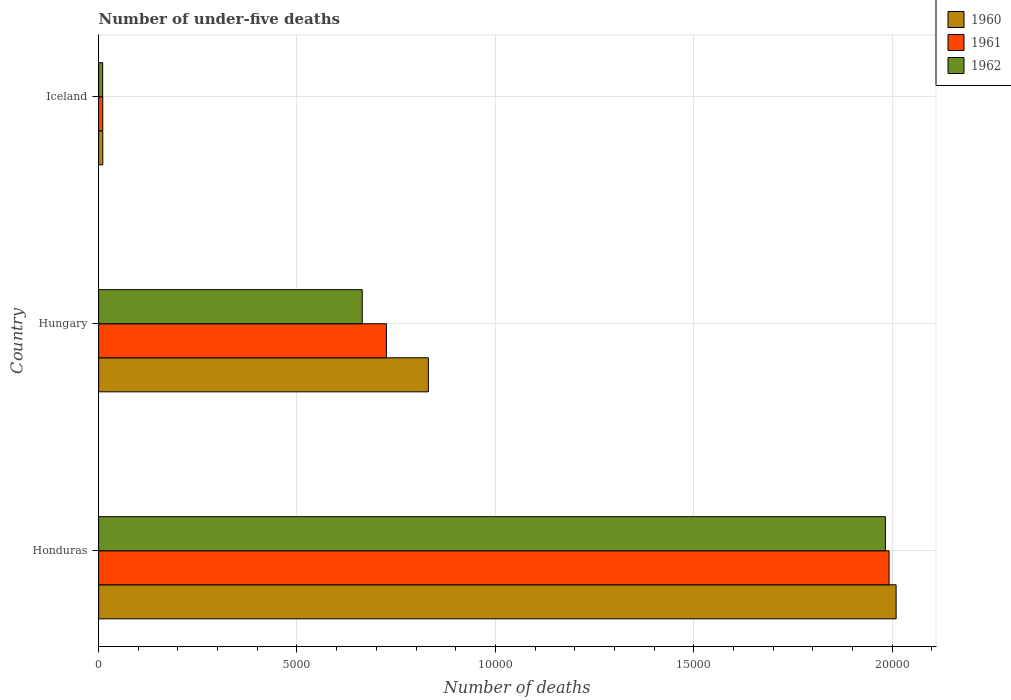How many groups of bars are there?
Give a very brief answer. 3. How many bars are there on the 1st tick from the bottom?
Make the answer very short. 3. What is the label of the 2nd group of bars from the top?
Provide a short and direct response. Hungary. In how many cases, is the number of bars for a given country not equal to the number of legend labels?
Offer a terse response. 0. What is the number of under-five deaths in 1962 in Hungary?
Offer a very short reply. 6645. Across all countries, what is the maximum number of under-five deaths in 1962?
Provide a succinct answer. 1.98e+04. Across all countries, what is the minimum number of under-five deaths in 1962?
Your response must be concise. 102. In which country was the number of under-five deaths in 1960 maximum?
Offer a terse response. Honduras. In which country was the number of under-five deaths in 1960 minimum?
Ensure brevity in your answer.  Iceland. What is the total number of under-five deaths in 1961 in the graph?
Keep it short and to the point. 2.73e+04. What is the difference between the number of under-five deaths in 1961 in Honduras and that in Hungary?
Provide a succinct answer. 1.27e+04. What is the difference between the number of under-five deaths in 1961 in Iceland and the number of under-five deaths in 1960 in Hungary?
Provide a succinct answer. -8208. What is the average number of under-five deaths in 1960 per country?
Your answer should be very brief. 9506.67. What is the difference between the number of under-five deaths in 1962 and number of under-five deaths in 1960 in Hungary?
Make the answer very short. -1667. In how many countries, is the number of under-five deaths in 1962 greater than 19000 ?
Keep it short and to the point. 1. What is the ratio of the number of under-five deaths in 1961 in Hungary to that in Iceland?
Keep it short and to the point. 69.76. Is the number of under-five deaths in 1961 in Honduras less than that in Hungary?
Your answer should be very brief. No. Is the difference between the number of under-five deaths in 1962 in Honduras and Hungary greater than the difference between the number of under-five deaths in 1960 in Honduras and Hungary?
Offer a very short reply. Yes. What is the difference between the highest and the second highest number of under-five deaths in 1962?
Provide a short and direct response. 1.32e+04. What is the difference between the highest and the lowest number of under-five deaths in 1960?
Your answer should be very brief. 2.00e+04. What does the 3rd bar from the bottom in Hungary represents?
Give a very brief answer. 1962. Is it the case that in every country, the sum of the number of under-five deaths in 1961 and number of under-five deaths in 1962 is greater than the number of under-five deaths in 1960?
Offer a terse response. Yes. How many countries are there in the graph?
Offer a terse response. 3. What is the difference between two consecutive major ticks on the X-axis?
Offer a terse response. 5000. Does the graph contain grids?
Give a very brief answer. Yes. Where does the legend appear in the graph?
Your answer should be compact. Top right. How are the legend labels stacked?
Keep it short and to the point. Vertical. What is the title of the graph?
Offer a very short reply. Number of under-five deaths. Does "1962" appear as one of the legend labels in the graph?
Your answer should be compact. Yes. What is the label or title of the X-axis?
Give a very brief answer. Number of deaths. What is the label or title of the Y-axis?
Ensure brevity in your answer.  Country. What is the Number of deaths of 1960 in Honduras?
Ensure brevity in your answer.  2.01e+04. What is the Number of deaths in 1961 in Honduras?
Offer a terse response. 1.99e+04. What is the Number of deaths of 1962 in Honduras?
Your answer should be compact. 1.98e+04. What is the Number of deaths in 1960 in Hungary?
Ensure brevity in your answer.  8312. What is the Number of deaths of 1961 in Hungary?
Offer a very short reply. 7255. What is the Number of deaths in 1962 in Hungary?
Your answer should be compact. 6645. What is the Number of deaths of 1960 in Iceland?
Make the answer very short. 105. What is the Number of deaths in 1961 in Iceland?
Keep it short and to the point. 104. What is the Number of deaths of 1962 in Iceland?
Your response must be concise. 102. Across all countries, what is the maximum Number of deaths of 1960?
Provide a short and direct response. 2.01e+04. Across all countries, what is the maximum Number of deaths of 1961?
Offer a terse response. 1.99e+04. Across all countries, what is the maximum Number of deaths in 1962?
Provide a succinct answer. 1.98e+04. Across all countries, what is the minimum Number of deaths of 1960?
Offer a terse response. 105. Across all countries, what is the minimum Number of deaths in 1961?
Give a very brief answer. 104. Across all countries, what is the minimum Number of deaths of 1962?
Ensure brevity in your answer.  102. What is the total Number of deaths in 1960 in the graph?
Keep it short and to the point. 2.85e+04. What is the total Number of deaths in 1961 in the graph?
Keep it short and to the point. 2.73e+04. What is the total Number of deaths in 1962 in the graph?
Provide a succinct answer. 2.66e+04. What is the difference between the Number of deaths of 1960 in Honduras and that in Hungary?
Your answer should be compact. 1.18e+04. What is the difference between the Number of deaths of 1961 in Honduras and that in Hungary?
Give a very brief answer. 1.27e+04. What is the difference between the Number of deaths of 1962 in Honduras and that in Hungary?
Keep it short and to the point. 1.32e+04. What is the difference between the Number of deaths of 1960 in Honduras and that in Iceland?
Offer a very short reply. 2.00e+04. What is the difference between the Number of deaths in 1961 in Honduras and that in Iceland?
Provide a short and direct response. 1.98e+04. What is the difference between the Number of deaths of 1962 in Honduras and that in Iceland?
Your response must be concise. 1.97e+04. What is the difference between the Number of deaths in 1960 in Hungary and that in Iceland?
Ensure brevity in your answer.  8207. What is the difference between the Number of deaths of 1961 in Hungary and that in Iceland?
Keep it short and to the point. 7151. What is the difference between the Number of deaths in 1962 in Hungary and that in Iceland?
Your answer should be compact. 6543. What is the difference between the Number of deaths of 1960 in Honduras and the Number of deaths of 1961 in Hungary?
Your answer should be compact. 1.28e+04. What is the difference between the Number of deaths in 1960 in Honduras and the Number of deaths in 1962 in Hungary?
Keep it short and to the point. 1.35e+04. What is the difference between the Number of deaths in 1961 in Honduras and the Number of deaths in 1962 in Hungary?
Ensure brevity in your answer.  1.33e+04. What is the difference between the Number of deaths of 1960 in Honduras and the Number of deaths of 1961 in Iceland?
Ensure brevity in your answer.  2.00e+04. What is the difference between the Number of deaths in 1960 in Honduras and the Number of deaths in 1962 in Iceland?
Ensure brevity in your answer.  2.00e+04. What is the difference between the Number of deaths in 1961 in Honduras and the Number of deaths in 1962 in Iceland?
Keep it short and to the point. 1.98e+04. What is the difference between the Number of deaths of 1960 in Hungary and the Number of deaths of 1961 in Iceland?
Give a very brief answer. 8208. What is the difference between the Number of deaths in 1960 in Hungary and the Number of deaths in 1962 in Iceland?
Offer a terse response. 8210. What is the difference between the Number of deaths of 1961 in Hungary and the Number of deaths of 1962 in Iceland?
Provide a short and direct response. 7153. What is the average Number of deaths of 1960 per country?
Keep it short and to the point. 9506.67. What is the average Number of deaths in 1961 per country?
Keep it short and to the point. 9094.67. What is the average Number of deaths of 1962 per country?
Your answer should be very brief. 8859.67. What is the difference between the Number of deaths in 1960 and Number of deaths in 1961 in Honduras?
Provide a short and direct response. 178. What is the difference between the Number of deaths in 1960 and Number of deaths in 1962 in Honduras?
Keep it short and to the point. 271. What is the difference between the Number of deaths in 1961 and Number of deaths in 1962 in Honduras?
Offer a terse response. 93. What is the difference between the Number of deaths of 1960 and Number of deaths of 1961 in Hungary?
Make the answer very short. 1057. What is the difference between the Number of deaths of 1960 and Number of deaths of 1962 in Hungary?
Offer a very short reply. 1667. What is the difference between the Number of deaths of 1961 and Number of deaths of 1962 in Hungary?
Keep it short and to the point. 610. What is the difference between the Number of deaths in 1960 and Number of deaths in 1961 in Iceland?
Make the answer very short. 1. What is the difference between the Number of deaths of 1961 and Number of deaths of 1962 in Iceland?
Your answer should be very brief. 2. What is the ratio of the Number of deaths of 1960 in Honduras to that in Hungary?
Ensure brevity in your answer.  2.42. What is the ratio of the Number of deaths of 1961 in Honduras to that in Hungary?
Offer a very short reply. 2.75. What is the ratio of the Number of deaths in 1962 in Honduras to that in Hungary?
Your answer should be compact. 2.98. What is the ratio of the Number of deaths in 1960 in Honduras to that in Iceland?
Your answer should be compact. 191.46. What is the ratio of the Number of deaths of 1961 in Honduras to that in Iceland?
Your response must be concise. 191.59. What is the ratio of the Number of deaths of 1962 in Honduras to that in Iceland?
Make the answer very short. 194.43. What is the ratio of the Number of deaths in 1960 in Hungary to that in Iceland?
Your response must be concise. 79.16. What is the ratio of the Number of deaths of 1961 in Hungary to that in Iceland?
Provide a short and direct response. 69.76. What is the ratio of the Number of deaths of 1962 in Hungary to that in Iceland?
Offer a terse response. 65.15. What is the difference between the highest and the second highest Number of deaths of 1960?
Ensure brevity in your answer.  1.18e+04. What is the difference between the highest and the second highest Number of deaths in 1961?
Your response must be concise. 1.27e+04. What is the difference between the highest and the second highest Number of deaths of 1962?
Ensure brevity in your answer.  1.32e+04. What is the difference between the highest and the lowest Number of deaths in 1960?
Give a very brief answer. 2.00e+04. What is the difference between the highest and the lowest Number of deaths in 1961?
Your answer should be very brief. 1.98e+04. What is the difference between the highest and the lowest Number of deaths in 1962?
Ensure brevity in your answer.  1.97e+04. 